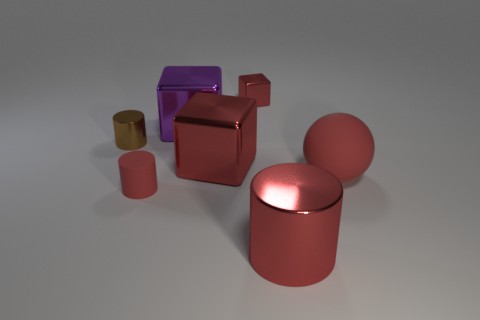Is the small cube the same color as the tiny rubber thing?
Your response must be concise. Yes. There is a rubber thing that is the same color as the matte ball; what shape is it?
Provide a short and direct response. Cylinder. Is there any other thing that is the same color as the large rubber object?
Your answer should be compact. Yes. What is the size of the ball that is the same color as the big shiny cylinder?
Your answer should be very brief. Large. There is a metallic block that is in front of the tiny brown metallic object; is its color the same as the matte cylinder?
Give a very brief answer. Yes. How many large things have the same color as the large matte ball?
Offer a very short reply. 2. Is the shape of the purple object the same as the tiny red metallic object?
Your answer should be compact. Yes. What is the color of the thing that is both on the left side of the large red rubber ball and right of the tiny shiny block?
Your answer should be compact. Red. Do the red block in front of the brown cylinder and the cylinder that is right of the small red cube have the same size?
Offer a very short reply. Yes. What number of objects are tiny red objects that are left of the small cube or brown shiny cylinders?
Provide a short and direct response. 2. 